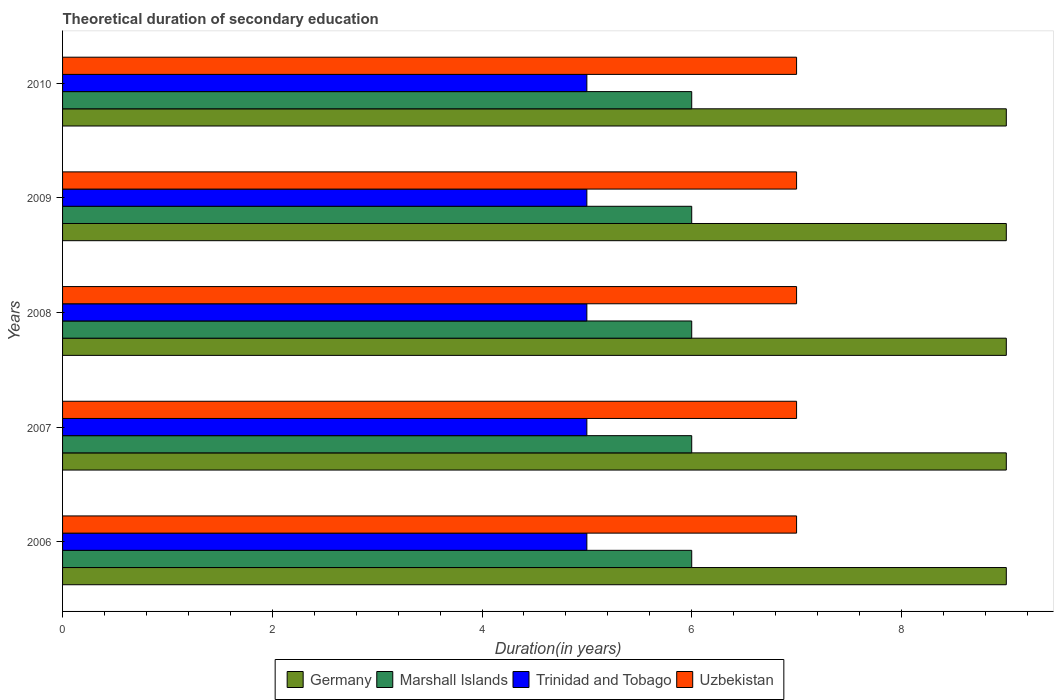How many groups of bars are there?
Offer a very short reply. 5. Are the number of bars per tick equal to the number of legend labels?
Give a very brief answer. Yes. How many bars are there on the 4th tick from the top?
Offer a very short reply. 4. How many bars are there on the 3rd tick from the bottom?
Keep it short and to the point. 4. What is the label of the 3rd group of bars from the top?
Offer a terse response. 2008. What is the total theoretical duration of secondary education in Uzbekistan in 2008?
Provide a short and direct response. 7. Across all years, what is the maximum total theoretical duration of secondary education in Germany?
Provide a short and direct response. 9. Across all years, what is the minimum total theoretical duration of secondary education in Uzbekistan?
Provide a succinct answer. 7. In which year was the total theoretical duration of secondary education in Germany maximum?
Provide a succinct answer. 2006. What is the total total theoretical duration of secondary education in Marshall Islands in the graph?
Provide a short and direct response. 30. What is the difference between the total theoretical duration of secondary education in Trinidad and Tobago in 2010 and the total theoretical duration of secondary education in Uzbekistan in 2008?
Your response must be concise. -2. What is the average total theoretical duration of secondary education in Uzbekistan per year?
Provide a succinct answer. 7. In the year 2009, what is the difference between the total theoretical duration of secondary education in Germany and total theoretical duration of secondary education in Marshall Islands?
Provide a short and direct response. 3. In how many years, is the total theoretical duration of secondary education in Germany greater than 7.2 years?
Provide a succinct answer. 5. What is the ratio of the total theoretical duration of secondary education in Trinidad and Tobago in 2007 to that in 2008?
Keep it short and to the point. 1. Is the difference between the total theoretical duration of secondary education in Germany in 2009 and 2010 greater than the difference between the total theoretical duration of secondary education in Marshall Islands in 2009 and 2010?
Keep it short and to the point. No. What is the difference between the highest and the second highest total theoretical duration of secondary education in Trinidad and Tobago?
Your answer should be compact. 0. In how many years, is the total theoretical duration of secondary education in Trinidad and Tobago greater than the average total theoretical duration of secondary education in Trinidad and Tobago taken over all years?
Offer a terse response. 0. Is it the case that in every year, the sum of the total theoretical duration of secondary education in Trinidad and Tobago and total theoretical duration of secondary education in Germany is greater than the sum of total theoretical duration of secondary education in Uzbekistan and total theoretical duration of secondary education in Marshall Islands?
Give a very brief answer. Yes. What does the 2nd bar from the top in 2010 represents?
Provide a succinct answer. Trinidad and Tobago. What does the 4th bar from the bottom in 2010 represents?
Offer a terse response. Uzbekistan. Is it the case that in every year, the sum of the total theoretical duration of secondary education in Trinidad and Tobago and total theoretical duration of secondary education in Uzbekistan is greater than the total theoretical duration of secondary education in Marshall Islands?
Make the answer very short. Yes. What is the difference between two consecutive major ticks on the X-axis?
Offer a terse response. 2. Are the values on the major ticks of X-axis written in scientific E-notation?
Ensure brevity in your answer.  No. Does the graph contain grids?
Your response must be concise. No. How many legend labels are there?
Ensure brevity in your answer.  4. How are the legend labels stacked?
Provide a succinct answer. Horizontal. What is the title of the graph?
Ensure brevity in your answer.  Theoretical duration of secondary education. What is the label or title of the X-axis?
Your answer should be very brief. Duration(in years). What is the label or title of the Y-axis?
Your answer should be very brief. Years. What is the Duration(in years) in Germany in 2006?
Ensure brevity in your answer.  9. What is the Duration(in years) in Uzbekistan in 2007?
Your answer should be very brief. 7. What is the Duration(in years) of Germany in 2009?
Offer a terse response. 9. What is the Duration(in years) of Trinidad and Tobago in 2009?
Give a very brief answer. 5. What is the Duration(in years) in Uzbekistan in 2009?
Provide a short and direct response. 7. What is the Duration(in years) in Trinidad and Tobago in 2010?
Provide a succinct answer. 5. Across all years, what is the maximum Duration(in years) of Germany?
Offer a very short reply. 9. Across all years, what is the maximum Duration(in years) in Marshall Islands?
Your response must be concise. 6. Across all years, what is the maximum Duration(in years) in Uzbekistan?
Provide a succinct answer. 7. Across all years, what is the minimum Duration(in years) of Marshall Islands?
Your response must be concise. 6. What is the total Duration(in years) of Germany in the graph?
Make the answer very short. 45. What is the difference between the Duration(in years) of Germany in 2006 and that in 2007?
Make the answer very short. 0. What is the difference between the Duration(in years) in Trinidad and Tobago in 2006 and that in 2008?
Keep it short and to the point. 0. What is the difference between the Duration(in years) in Germany in 2006 and that in 2009?
Your answer should be compact. 0. What is the difference between the Duration(in years) of Trinidad and Tobago in 2006 and that in 2009?
Give a very brief answer. 0. What is the difference between the Duration(in years) of Uzbekistan in 2006 and that in 2009?
Offer a terse response. 0. What is the difference between the Duration(in years) of Uzbekistan in 2006 and that in 2010?
Make the answer very short. 0. What is the difference between the Duration(in years) of Germany in 2007 and that in 2008?
Offer a terse response. 0. What is the difference between the Duration(in years) in Marshall Islands in 2007 and that in 2008?
Your answer should be compact. 0. What is the difference between the Duration(in years) in Trinidad and Tobago in 2007 and that in 2008?
Keep it short and to the point. 0. What is the difference between the Duration(in years) in Uzbekistan in 2007 and that in 2008?
Ensure brevity in your answer.  0. What is the difference between the Duration(in years) of Trinidad and Tobago in 2007 and that in 2009?
Provide a succinct answer. 0. What is the difference between the Duration(in years) of Germany in 2007 and that in 2010?
Offer a terse response. 0. What is the difference between the Duration(in years) of Marshall Islands in 2007 and that in 2010?
Your response must be concise. 0. What is the difference between the Duration(in years) of Uzbekistan in 2008 and that in 2009?
Provide a succinct answer. 0. What is the difference between the Duration(in years) in Marshall Islands in 2008 and that in 2010?
Make the answer very short. 0. What is the difference between the Duration(in years) in Trinidad and Tobago in 2008 and that in 2010?
Ensure brevity in your answer.  0. What is the difference between the Duration(in years) of Marshall Islands in 2009 and that in 2010?
Your answer should be compact. 0. What is the difference between the Duration(in years) of Germany in 2006 and the Duration(in years) of Trinidad and Tobago in 2007?
Your answer should be compact. 4. What is the difference between the Duration(in years) in Marshall Islands in 2006 and the Duration(in years) in Trinidad and Tobago in 2007?
Make the answer very short. 1. What is the difference between the Duration(in years) of Germany in 2006 and the Duration(in years) of Marshall Islands in 2008?
Provide a succinct answer. 3. What is the difference between the Duration(in years) in Marshall Islands in 2006 and the Duration(in years) in Trinidad and Tobago in 2008?
Your answer should be compact. 1. What is the difference between the Duration(in years) in Marshall Islands in 2006 and the Duration(in years) in Uzbekistan in 2008?
Your answer should be very brief. -1. What is the difference between the Duration(in years) in Germany in 2006 and the Duration(in years) in Marshall Islands in 2009?
Give a very brief answer. 3. What is the difference between the Duration(in years) of Marshall Islands in 2006 and the Duration(in years) of Uzbekistan in 2009?
Give a very brief answer. -1. What is the difference between the Duration(in years) of Trinidad and Tobago in 2006 and the Duration(in years) of Uzbekistan in 2009?
Give a very brief answer. -2. What is the difference between the Duration(in years) in Germany in 2006 and the Duration(in years) in Marshall Islands in 2010?
Offer a terse response. 3. What is the difference between the Duration(in years) in Germany in 2006 and the Duration(in years) in Trinidad and Tobago in 2010?
Offer a terse response. 4. What is the difference between the Duration(in years) in Marshall Islands in 2006 and the Duration(in years) in Trinidad and Tobago in 2010?
Make the answer very short. 1. What is the difference between the Duration(in years) of Marshall Islands in 2006 and the Duration(in years) of Uzbekistan in 2010?
Make the answer very short. -1. What is the difference between the Duration(in years) in Trinidad and Tobago in 2006 and the Duration(in years) in Uzbekistan in 2010?
Make the answer very short. -2. What is the difference between the Duration(in years) in Germany in 2007 and the Duration(in years) in Marshall Islands in 2008?
Your answer should be very brief. 3. What is the difference between the Duration(in years) of Germany in 2007 and the Duration(in years) of Trinidad and Tobago in 2008?
Your response must be concise. 4. What is the difference between the Duration(in years) of Germany in 2007 and the Duration(in years) of Uzbekistan in 2008?
Your answer should be very brief. 2. What is the difference between the Duration(in years) in Marshall Islands in 2007 and the Duration(in years) in Trinidad and Tobago in 2008?
Provide a succinct answer. 1. What is the difference between the Duration(in years) of Marshall Islands in 2007 and the Duration(in years) of Uzbekistan in 2008?
Offer a terse response. -1. What is the difference between the Duration(in years) of Germany in 2007 and the Duration(in years) of Trinidad and Tobago in 2009?
Your answer should be very brief. 4. What is the difference between the Duration(in years) of Marshall Islands in 2007 and the Duration(in years) of Trinidad and Tobago in 2009?
Ensure brevity in your answer.  1. What is the difference between the Duration(in years) in Marshall Islands in 2007 and the Duration(in years) in Uzbekistan in 2009?
Keep it short and to the point. -1. What is the difference between the Duration(in years) of Marshall Islands in 2007 and the Duration(in years) of Uzbekistan in 2010?
Your response must be concise. -1. What is the difference between the Duration(in years) in Trinidad and Tobago in 2007 and the Duration(in years) in Uzbekistan in 2010?
Offer a terse response. -2. What is the difference between the Duration(in years) in Germany in 2008 and the Duration(in years) in Marshall Islands in 2009?
Provide a succinct answer. 3. What is the difference between the Duration(in years) of Germany in 2008 and the Duration(in years) of Trinidad and Tobago in 2009?
Your response must be concise. 4. What is the difference between the Duration(in years) in Germany in 2008 and the Duration(in years) in Uzbekistan in 2009?
Give a very brief answer. 2. What is the difference between the Duration(in years) of Marshall Islands in 2008 and the Duration(in years) of Trinidad and Tobago in 2009?
Keep it short and to the point. 1. What is the difference between the Duration(in years) of Germany in 2008 and the Duration(in years) of Trinidad and Tobago in 2010?
Ensure brevity in your answer.  4. What is the difference between the Duration(in years) in Marshall Islands in 2008 and the Duration(in years) in Trinidad and Tobago in 2010?
Your answer should be very brief. 1. What is the difference between the Duration(in years) of Germany in 2009 and the Duration(in years) of Marshall Islands in 2010?
Give a very brief answer. 3. What is the difference between the Duration(in years) in Germany in 2009 and the Duration(in years) in Uzbekistan in 2010?
Provide a short and direct response. 2. What is the difference between the Duration(in years) in Marshall Islands in 2009 and the Duration(in years) in Trinidad and Tobago in 2010?
Offer a very short reply. 1. What is the difference between the Duration(in years) in Marshall Islands in 2009 and the Duration(in years) in Uzbekistan in 2010?
Offer a terse response. -1. What is the average Duration(in years) in Germany per year?
Your response must be concise. 9. In the year 2006, what is the difference between the Duration(in years) of Germany and Duration(in years) of Trinidad and Tobago?
Offer a very short reply. 4. In the year 2006, what is the difference between the Duration(in years) of Marshall Islands and Duration(in years) of Trinidad and Tobago?
Provide a short and direct response. 1. In the year 2007, what is the difference between the Duration(in years) in Germany and Duration(in years) in Marshall Islands?
Offer a very short reply. 3. In the year 2007, what is the difference between the Duration(in years) in Germany and Duration(in years) in Trinidad and Tobago?
Make the answer very short. 4. In the year 2007, what is the difference between the Duration(in years) in Marshall Islands and Duration(in years) in Uzbekistan?
Offer a very short reply. -1. In the year 2007, what is the difference between the Duration(in years) of Trinidad and Tobago and Duration(in years) of Uzbekistan?
Your answer should be very brief. -2. In the year 2008, what is the difference between the Duration(in years) in Germany and Duration(in years) in Marshall Islands?
Offer a terse response. 3. In the year 2008, what is the difference between the Duration(in years) of Marshall Islands and Duration(in years) of Uzbekistan?
Give a very brief answer. -1. In the year 2009, what is the difference between the Duration(in years) in Germany and Duration(in years) in Trinidad and Tobago?
Make the answer very short. 4. In the year 2009, what is the difference between the Duration(in years) in Marshall Islands and Duration(in years) in Trinidad and Tobago?
Your response must be concise. 1. In the year 2009, what is the difference between the Duration(in years) in Marshall Islands and Duration(in years) in Uzbekistan?
Keep it short and to the point. -1. In the year 2009, what is the difference between the Duration(in years) of Trinidad and Tobago and Duration(in years) of Uzbekistan?
Your answer should be compact. -2. In the year 2010, what is the difference between the Duration(in years) in Germany and Duration(in years) in Uzbekistan?
Your answer should be very brief. 2. In the year 2010, what is the difference between the Duration(in years) in Marshall Islands and Duration(in years) in Uzbekistan?
Make the answer very short. -1. What is the ratio of the Duration(in years) in Germany in 2006 to that in 2007?
Keep it short and to the point. 1. What is the ratio of the Duration(in years) of Marshall Islands in 2006 to that in 2007?
Make the answer very short. 1. What is the ratio of the Duration(in years) in Trinidad and Tobago in 2006 to that in 2007?
Provide a succinct answer. 1. What is the ratio of the Duration(in years) in Trinidad and Tobago in 2006 to that in 2008?
Your answer should be compact. 1. What is the ratio of the Duration(in years) in Germany in 2006 to that in 2009?
Your answer should be compact. 1. What is the ratio of the Duration(in years) of Marshall Islands in 2006 to that in 2009?
Your response must be concise. 1. What is the ratio of the Duration(in years) in Trinidad and Tobago in 2006 to that in 2009?
Offer a terse response. 1. What is the ratio of the Duration(in years) in Uzbekistan in 2006 to that in 2009?
Your response must be concise. 1. What is the ratio of the Duration(in years) in Germany in 2006 to that in 2010?
Ensure brevity in your answer.  1. What is the ratio of the Duration(in years) in Trinidad and Tobago in 2006 to that in 2010?
Provide a succinct answer. 1. What is the ratio of the Duration(in years) of Uzbekistan in 2006 to that in 2010?
Ensure brevity in your answer.  1. What is the ratio of the Duration(in years) in Marshall Islands in 2007 to that in 2008?
Offer a very short reply. 1. What is the ratio of the Duration(in years) of Trinidad and Tobago in 2007 to that in 2008?
Your answer should be compact. 1. What is the ratio of the Duration(in years) of Germany in 2007 to that in 2009?
Offer a terse response. 1. What is the ratio of the Duration(in years) in Marshall Islands in 2007 to that in 2009?
Ensure brevity in your answer.  1. What is the ratio of the Duration(in years) in Trinidad and Tobago in 2007 to that in 2009?
Offer a very short reply. 1. What is the ratio of the Duration(in years) of Uzbekistan in 2007 to that in 2009?
Your answer should be very brief. 1. What is the ratio of the Duration(in years) in Trinidad and Tobago in 2007 to that in 2010?
Your answer should be compact. 1. What is the ratio of the Duration(in years) in Uzbekistan in 2007 to that in 2010?
Make the answer very short. 1. What is the ratio of the Duration(in years) of Germany in 2008 to that in 2010?
Keep it short and to the point. 1. What is the ratio of the Duration(in years) of Marshall Islands in 2008 to that in 2010?
Provide a succinct answer. 1. What is the ratio of the Duration(in years) of Germany in 2009 to that in 2010?
Give a very brief answer. 1. What is the difference between the highest and the second highest Duration(in years) in Germany?
Make the answer very short. 0. What is the difference between the highest and the second highest Duration(in years) of Marshall Islands?
Give a very brief answer. 0. What is the difference between the highest and the second highest Duration(in years) in Trinidad and Tobago?
Provide a short and direct response. 0. What is the difference between the highest and the lowest Duration(in years) in Germany?
Keep it short and to the point. 0. What is the difference between the highest and the lowest Duration(in years) of Trinidad and Tobago?
Offer a terse response. 0. What is the difference between the highest and the lowest Duration(in years) in Uzbekistan?
Make the answer very short. 0. 